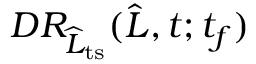Convert formula to latex. <formula><loc_0><loc_0><loc_500><loc_500>D R _ { \widehat { L } _ { t s } } ( \widehat { L } , t ; t _ { f } )</formula> 